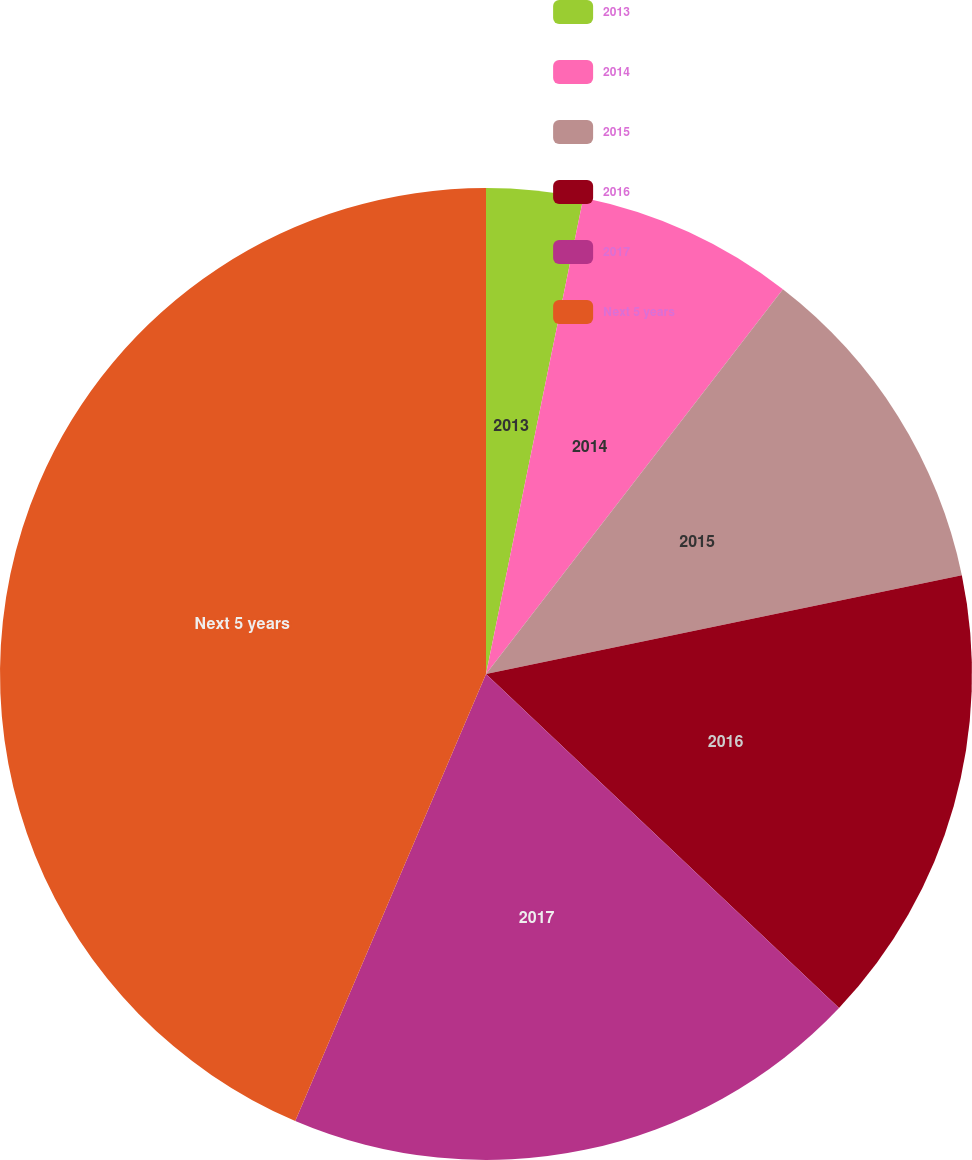Convert chart. <chart><loc_0><loc_0><loc_500><loc_500><pie_chart><fcel>2013<fcel>2014<fcel>2015<fcel>2016<fcel>2017<fcel>Next 5 years<nl><fcel>3.21%<fcel>7.25%<fcel>11.28%<fcel>15.32%<fcel>19.36%<fcel>43.58%<nl></chart> 